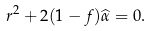<formula> <loc_0><loc_0><loc_500><loc_500>r ^ { 2 } + 2 ( 1 - f ) \widehat { \alpha } = 0 .</formula> 